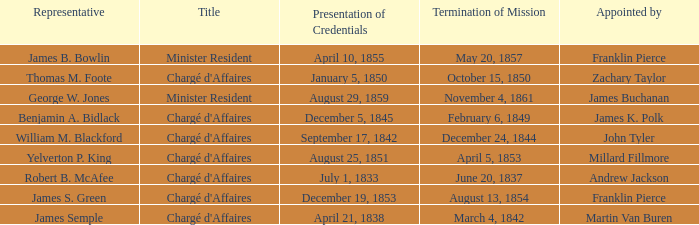What Title has a Termination of Mission of November 4, 1861? Minister Resident. 